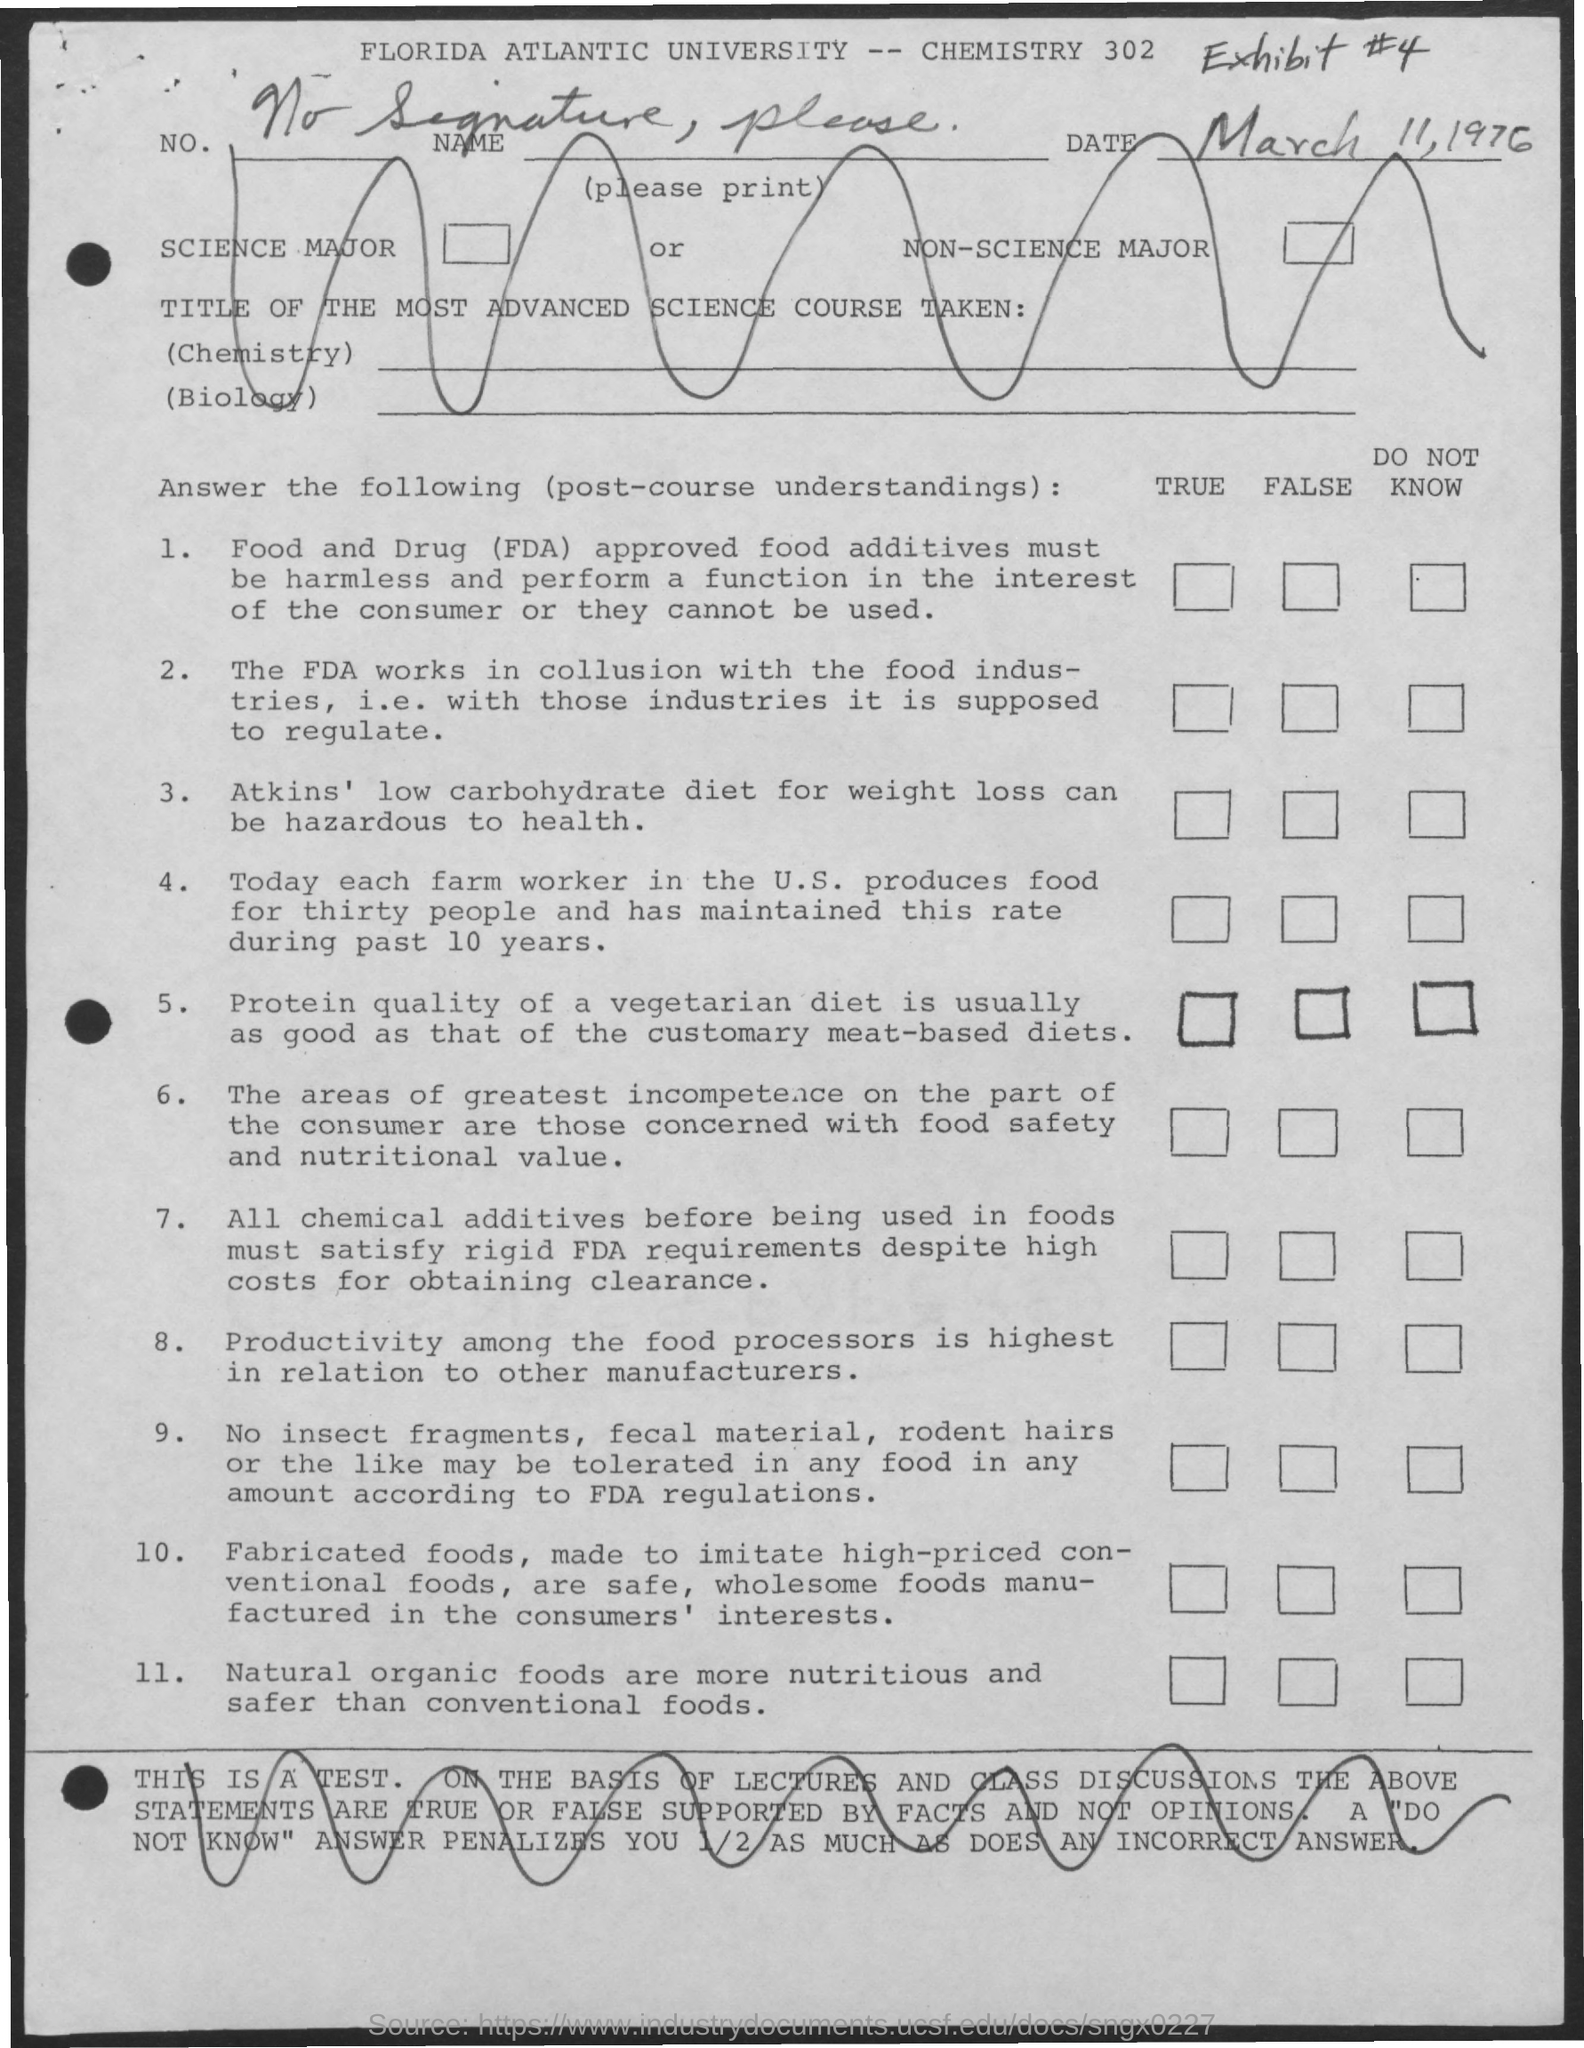Indicate a few pertinent items in this graphic. Florida Atlantic University is mentioned at the top. The date mentioned at the top right is March 11, 1976. 